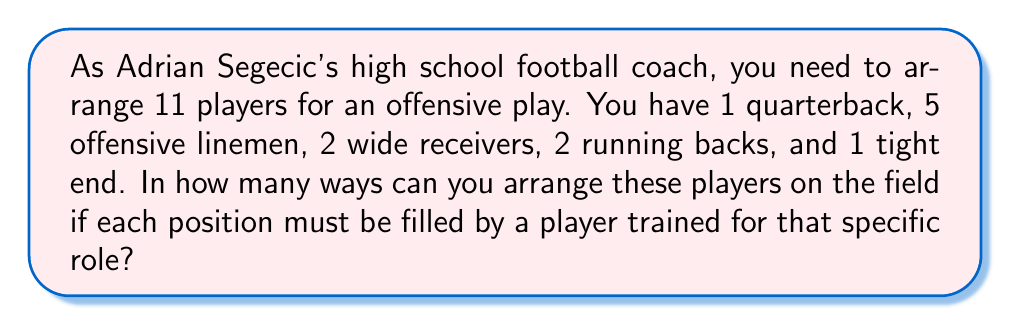Give your solution to this math problem. Let's approach this step-by-step:

1) First, we need to understand that this is a permutation problem where we are arranging players within their specific position groups.

2) For each position group, we need to calculate the number of ways to arrange the players:

   - Quarterback: Only 1 player, so only 1 way to arrange: $1!$
   - Offensive linemen: 5 players, so $5!$ ways to arrange
   - Wide receivers: 2 players, so $2!$ ways to arrange
   - Running backs: 2 players, so $2!$ ways to arrange
   - Tight end: Only 1 player, so only 1 way to arrange: $1!$

3) According to the multiplication principle, to find the total number of arrangements, we multiply the number of ways for each position group:

   $$ \text{Total arrangements} = 1! \times 5! \times 2! \times 2! \times 1! $$

4) Let's calculate this:
   $$ 1 \times 120 \times 2 \times 2 \times 1 = 480 $$

Therefore, there are 480 different ways to arrange the players on the field.
Answer: 480 